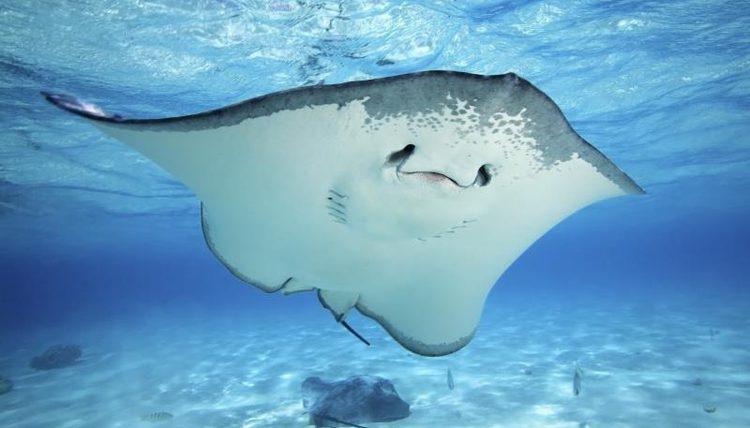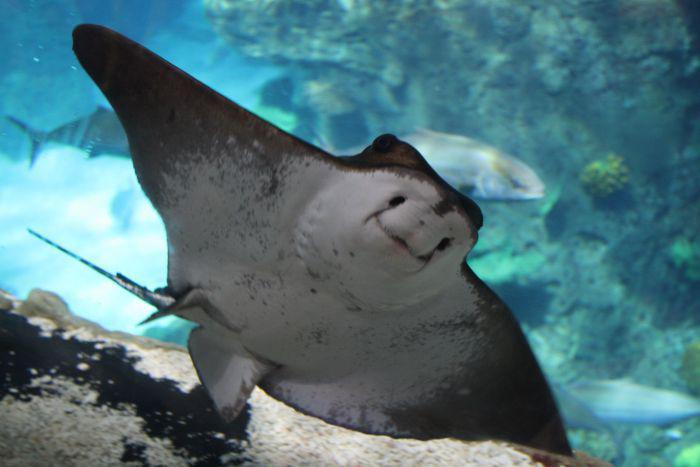The first image is the image on the left, the second image is the image on the right. For the images shown, is this caption "At least one stingray's underside is visible." true? Answer yes or no. Yes. 